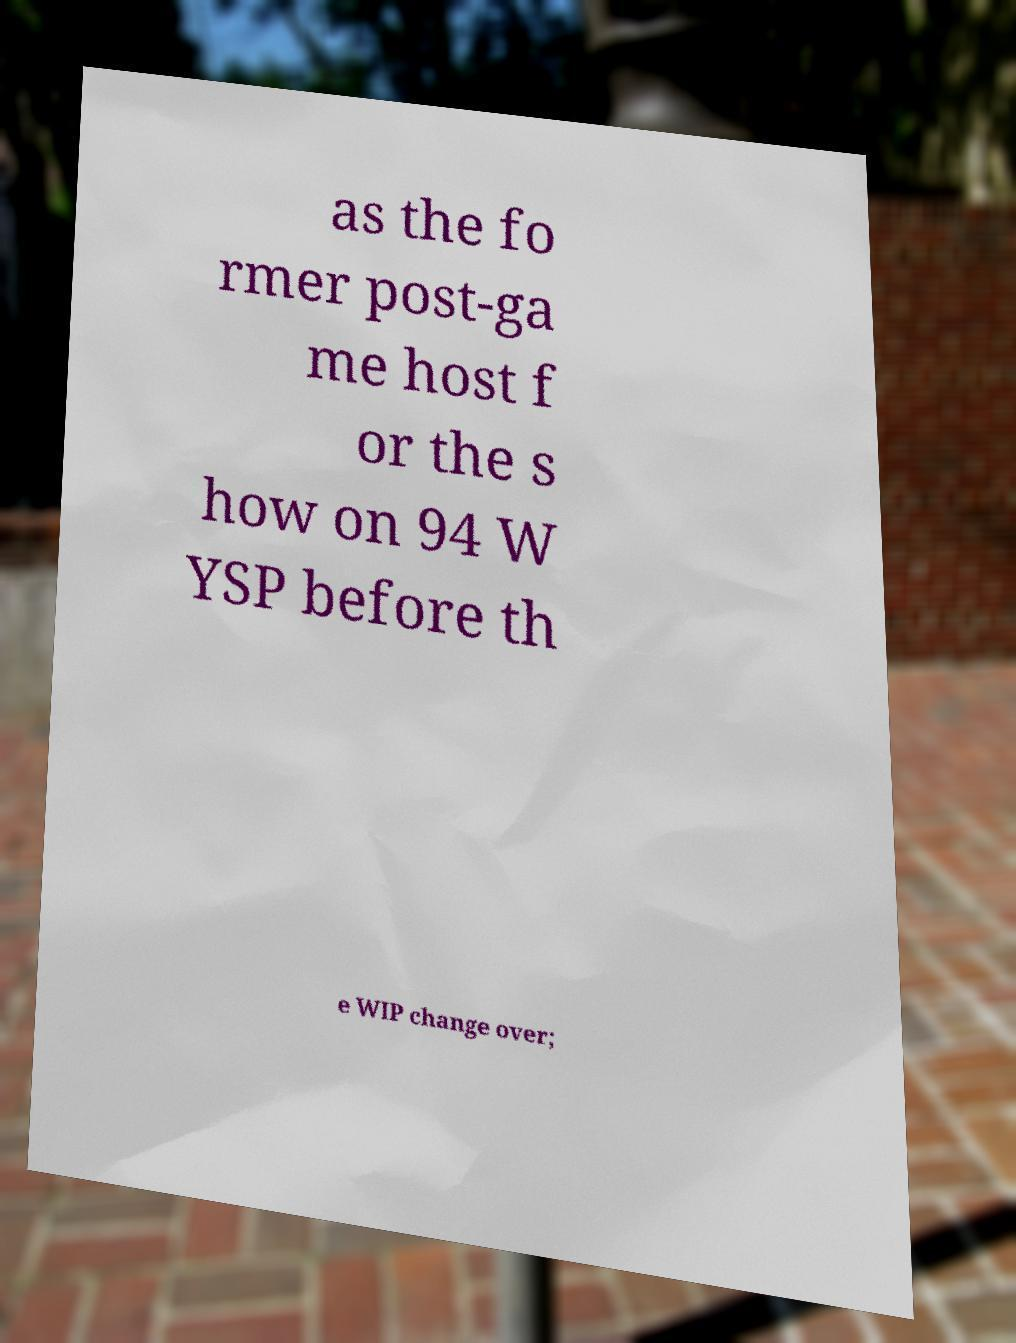Please read and relay the text visible in this image. What does it say? as the fo rmer post-ga me host f or the s how on 94 W YSP before th e WIP change over; 